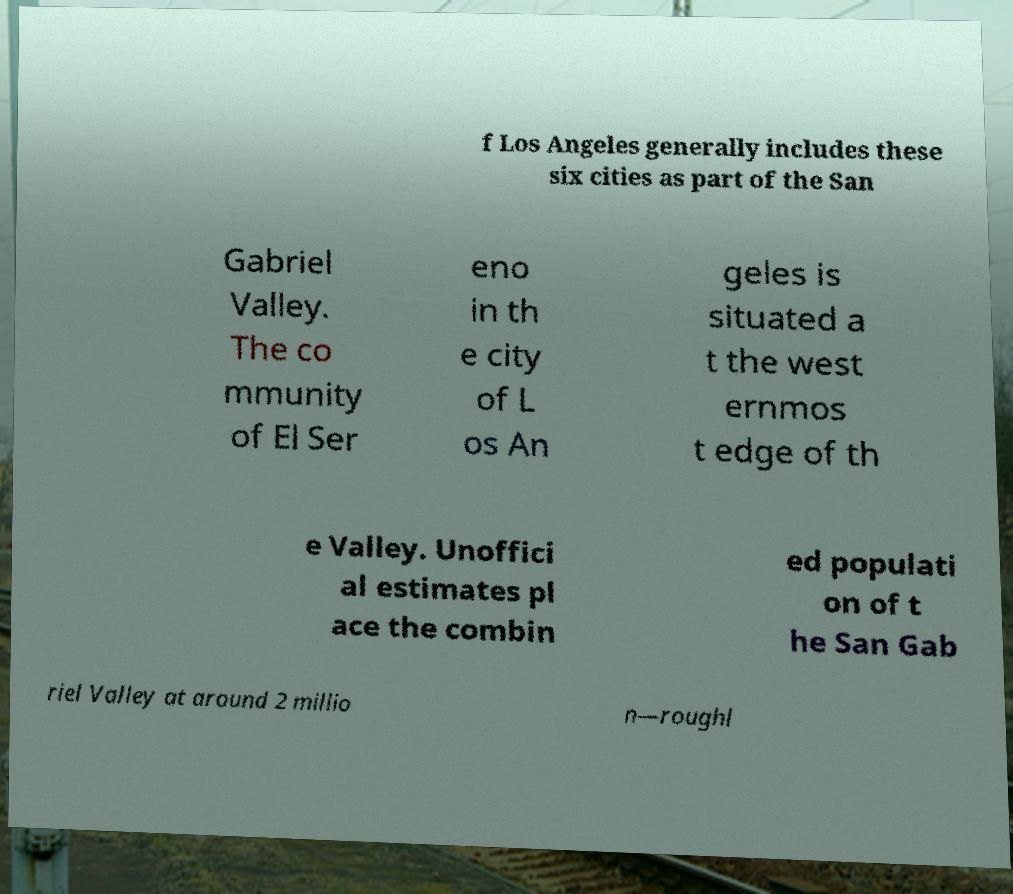I need the written content from this picture converted into text. Can you do that? f Los Angeles generally includes these six cities as part of the San Gabriel Valley. The co mmunity of El Ser eno in th e city of L os An geles is situated a t the west ernmos t edge of th e Valley. Unoffici al estimates pl ace the combin ed populati on of t he San Gab riel Valley at around 2 millio n—roughl 